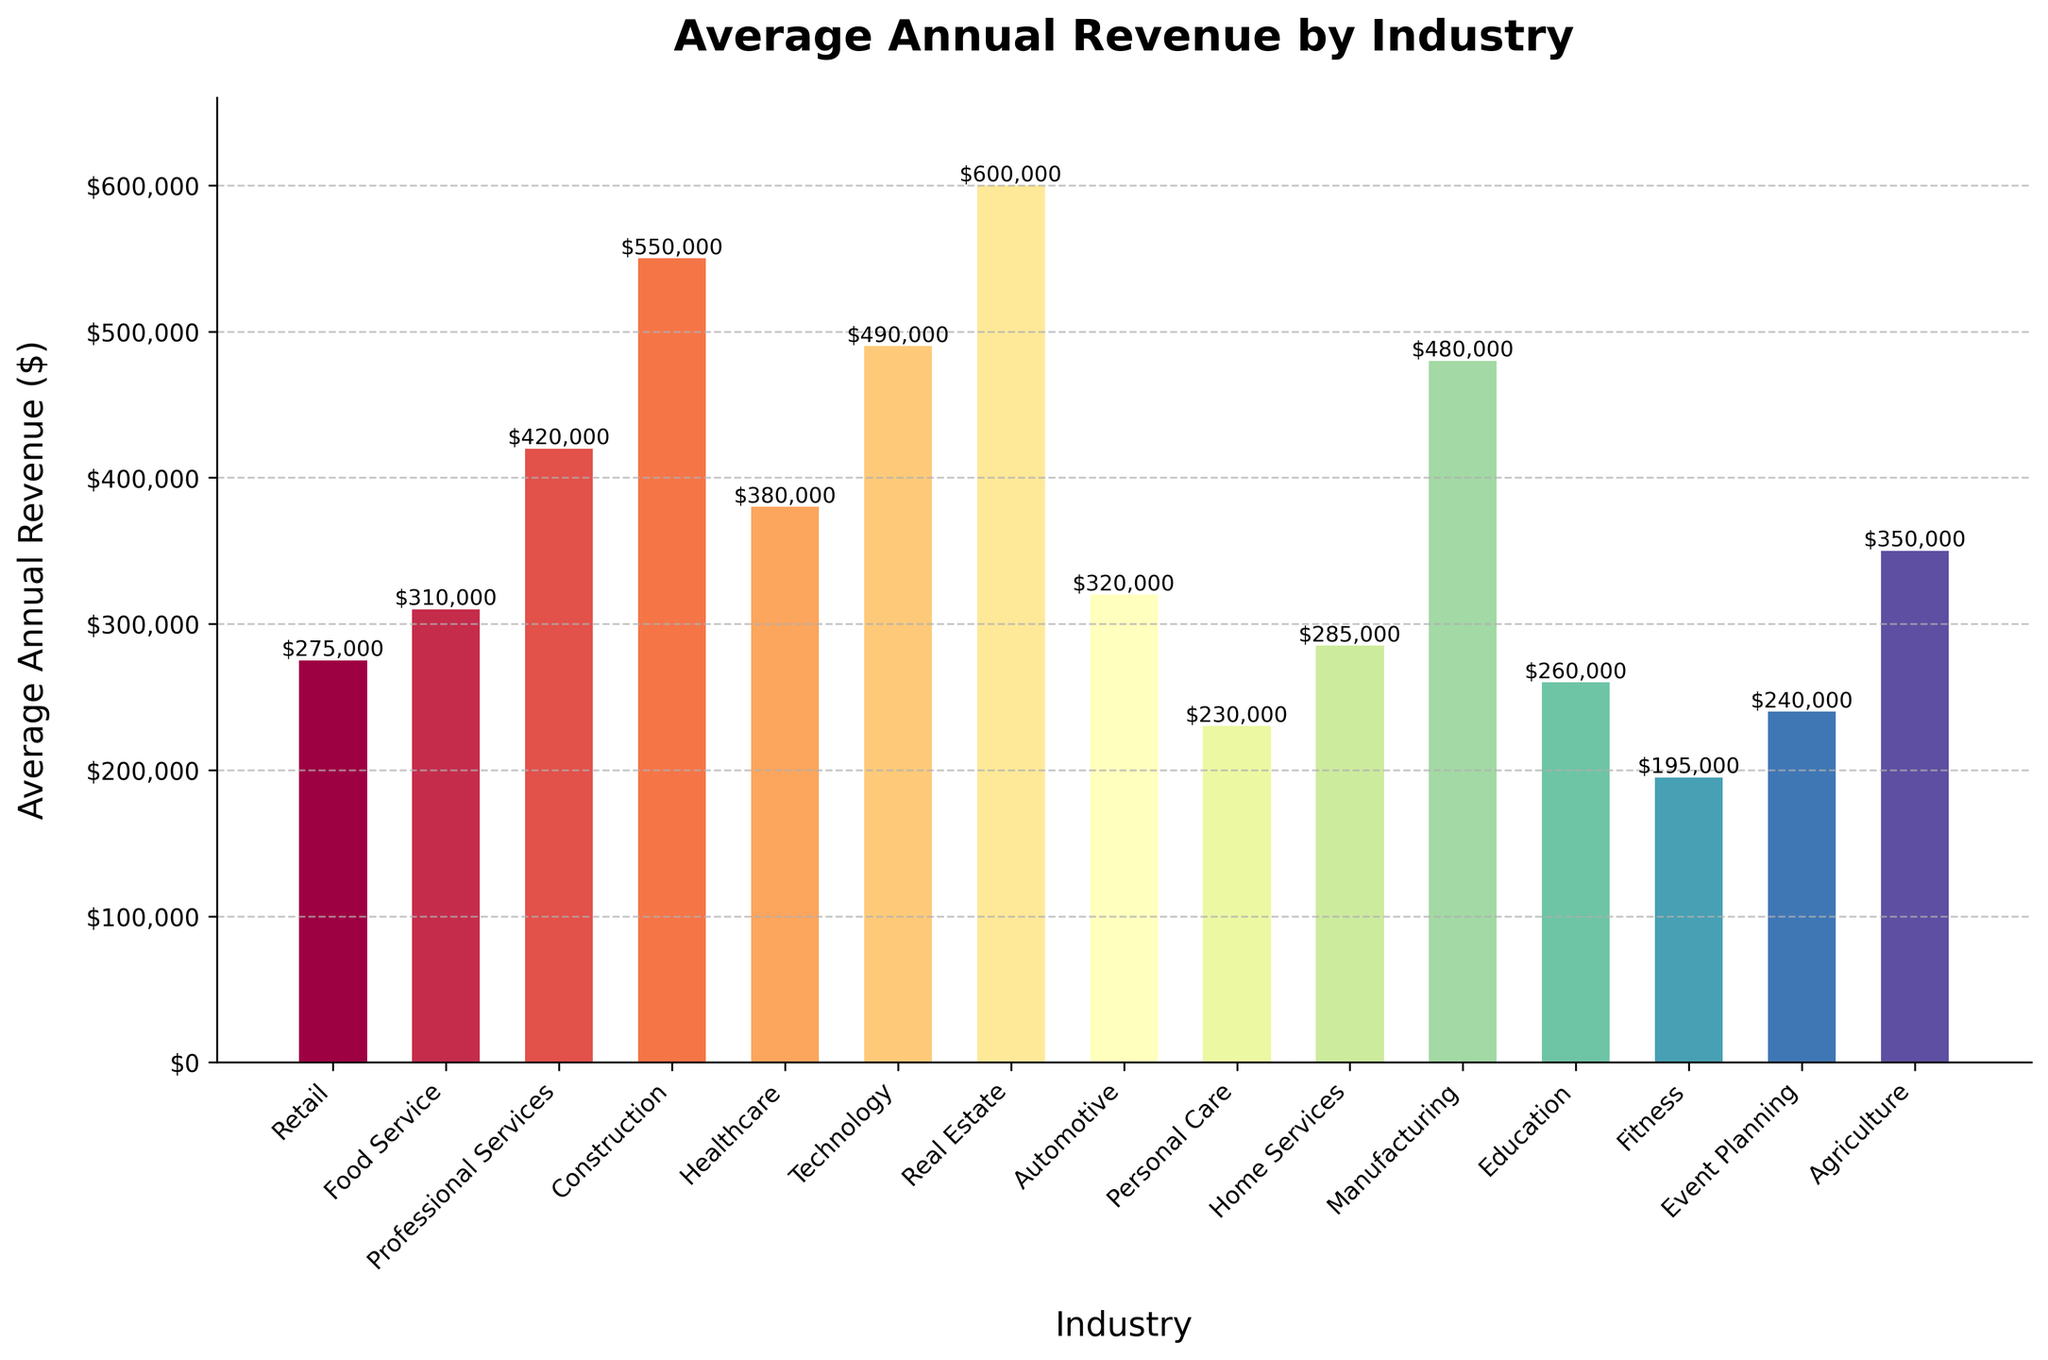Which industry has the highest average annual revenue? The bar representing the "Real Estate" industry has the greatest height on the chart, indicating the highest average annual revenue.
Answer: Real Estate Which industry has the lowest average annual revenue? The "Fitness" industry has the shortest bar on the chart, indicating the lowest average annual revenue.
Answer: Fitness What is the difference in average annual revenue between the Technology and Retail industries? The average annual revenue for "Technology" is $490,000, and for "Retail" it is $275,000. The difference is $490,000 - $275,000.
Answer: $215,000 Which two industries have revenues that are closest in value? The bars for "Food Service" ($310,000) and "Automotive" ($320,000) are very close in height, indicating similar revenues.
Answer: Food Service and Automotive By how much does the average annual revenue of the Construction industry exceed that of the Healthcare industry? The average annual revenue for "Construction" is $550,000, and for "Healthcare" it is $380,000. The difference is $550,000 - $380,000.
Answer: $170,000 Which industry has around $500,000 in average annual revenue? The "Manufacturing" industry has a bar near $500,000, specifically $480,000.
Answer: Manufacturing Add up the average annual revenues of the three industries with the lowest values. What is the total? The three lowest are "Fitness" ($195,000), "Event Planning" ($240,000), and "Personal Care" ($230,000). Total is $195,000 + $240,000 + $230,000.
Answer: $665,000 Which industry is more profitable: Education or Agriculture? The bar for "Agriculture" is taller than that for "Education," indicating a higher revenue.
Answer: Agriculture What is the average annual revenue for industries with bars colored blue? The bars' colors span a spectrum and do not isolate any industry specifically by color in this chart. This aspect doesn’t aid in determining individual industry revenues here, so this question cannot be directly answered from the figure.
Answer: Not answerable from the chart Name the industry with an average annual revenue closest to $275,000. The industry "Retail" has an average annual revenue of $275,000.
Answer: Retail 